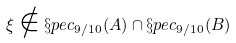<formula> <loc_0><loc_0><loc_500><loc_500>\xi \notin \S p e c _ { 9 / 1 0 } ( A ) \cap \S p e c _ { 9 / 1 0 } ( B )</formula> 